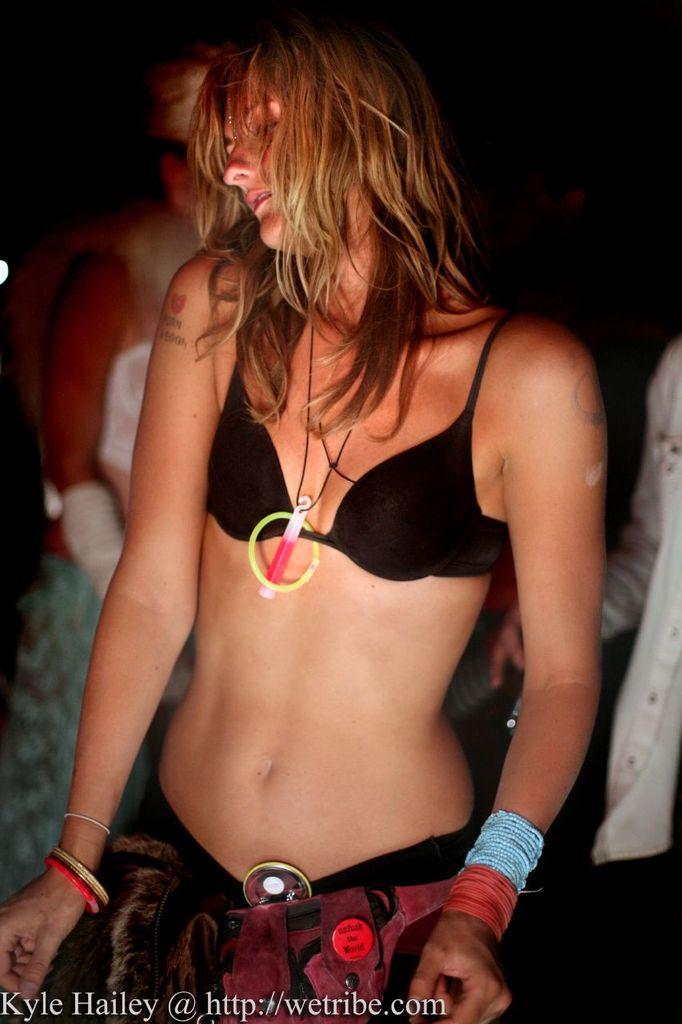Could you give a brief overview of what you see in this image? In the middle of the image we can see a woman. There is a dark background and we can see two persons. At the bottom of the image we can see something is written on it. 